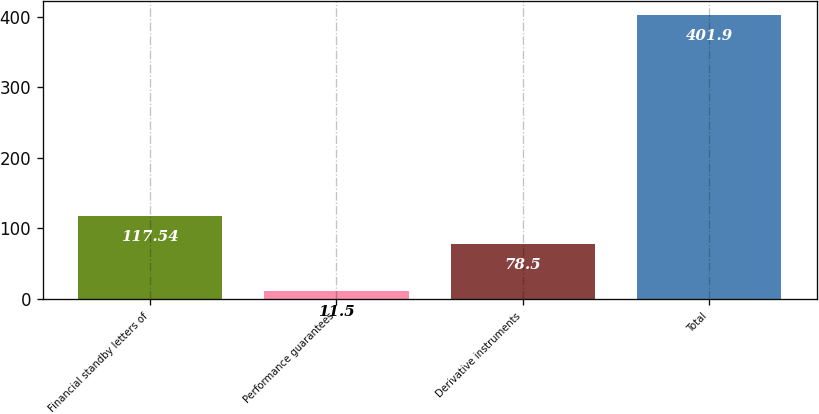Convert chart. <chart><loc_0><loc_0><loc_500><loc_500><bar_chart><fcel>Financial standby letters of<fcel>Performance guarantees<fcel>Derivative instruments<fcel>Total<nl><fcel>117.54<fcel>11.5<fcel>78.5<fcel>401.9<nl></chart> 